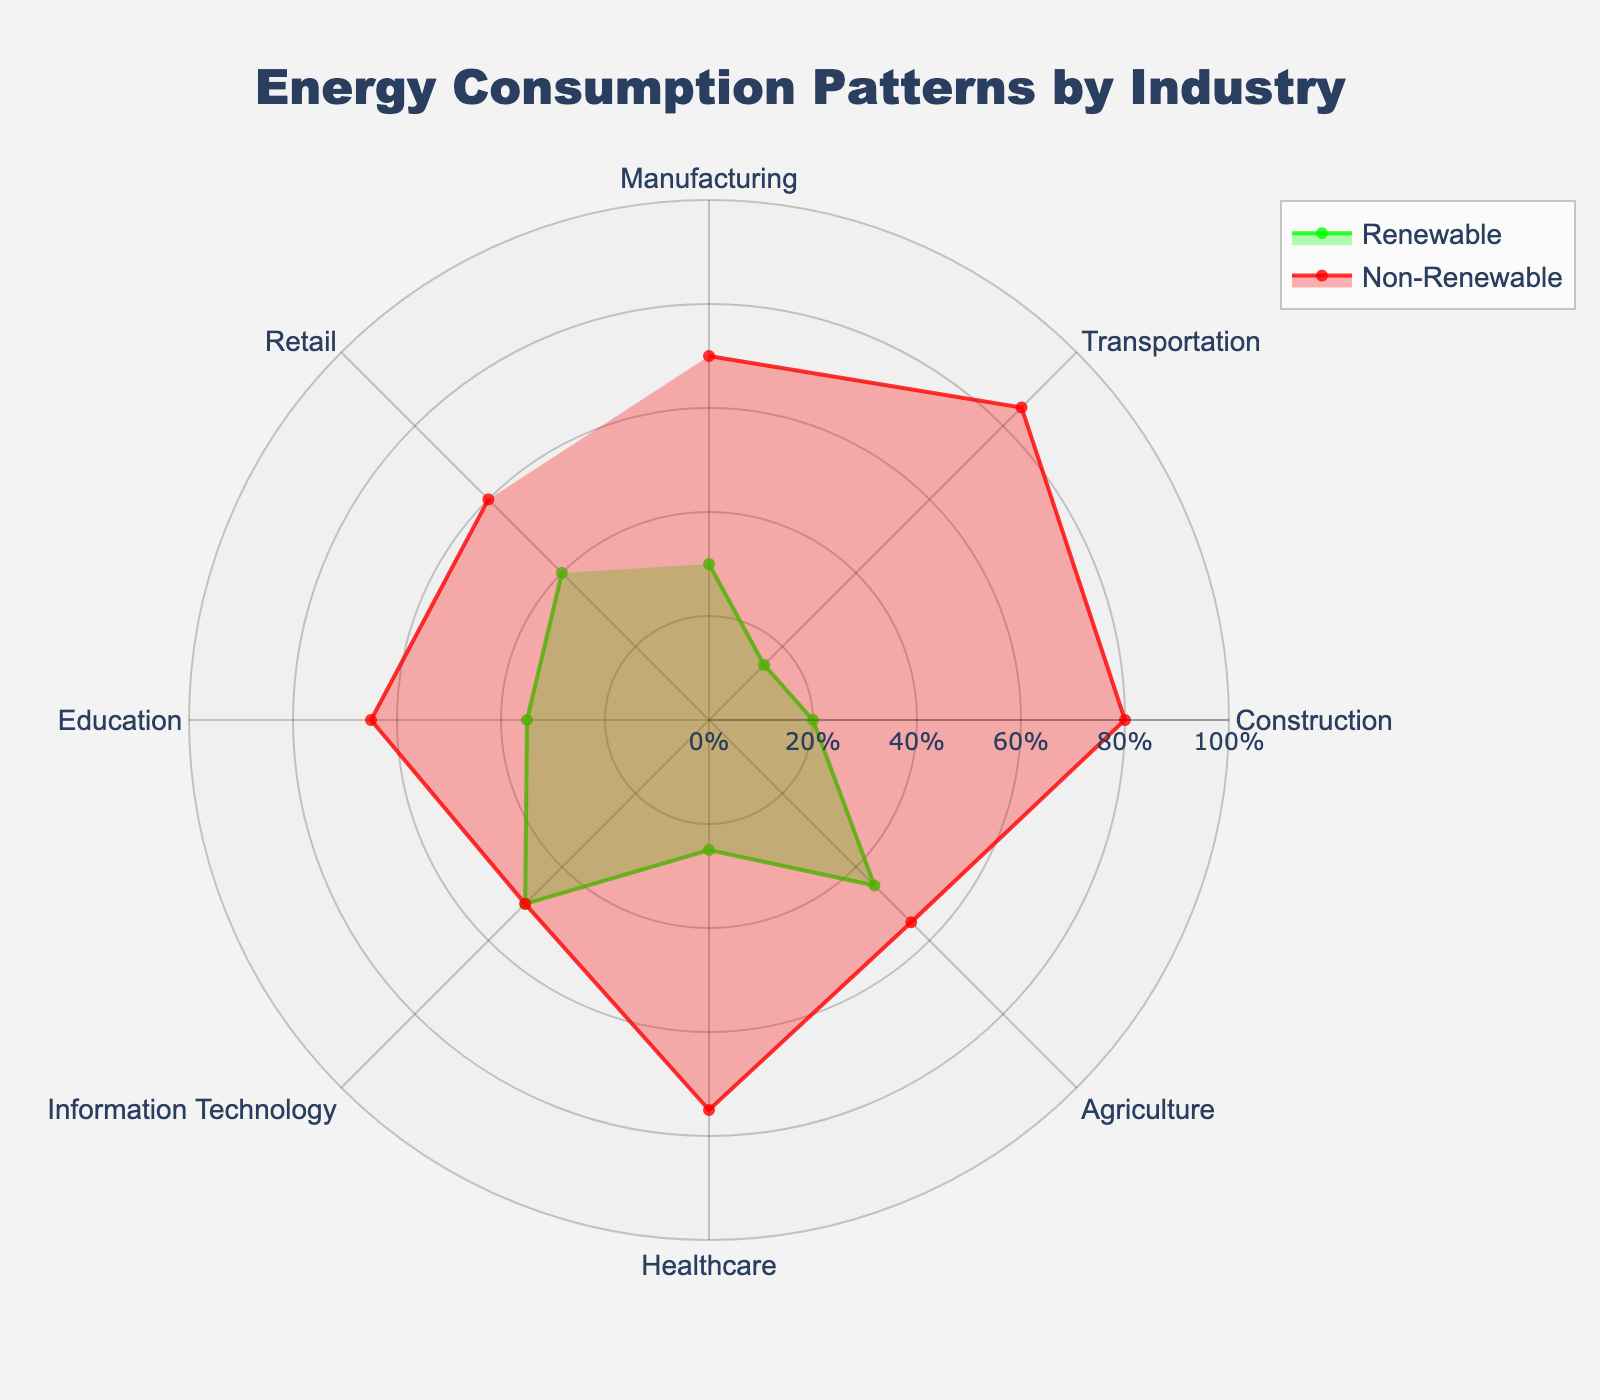What are the two main energy types represented in the chart? The chart shows two main energy types: Renewable and Non-Renewable. These types are plotted with distinct colors and visual markers.
Answer: Renewable and Non-Renewable Which industry has the highest percentage of renewable energy? In the chart, each industry is labeled, and their renewable energy percentages can be directly seen. Agriculture has the highest percentage of renewable energy at 45%.
Answer: Agriculture What is the title of the chart? The title is usually prominently displayed at the top of the chart. For this figure, the title is "Energy Consumption Patterns by Industry".
Answer: Energy Consumption Patterns by Industry Which industry has an equal distribution of renewable and non-renewable energy sources? By examining the percentages for each industry, Information Technology shows a 50/50 split between renewable and non-renewable energy.
Answer: Information Technology How much is the difference in renewable energy usage between Retail and Transportation? Retail has 40% renewable energy whereas Transportation has 15%. The difference is calculated as 40% - 15% = 25%.
Answer: 25% Which industry has the smallest percentage of renewable energy? The chart shows the renewable percentages for all industries, and Transportation has the smallest percentage at 15%.
Answer: Transportation Compare the renewable energy usage of the Healthcare and Education sectors. Which one is higher? Healthcare uses 25% renewable energy while Education uses 35%. Thus, Education has a higher percentage of renewable energy usage.
Answer: Education What is the average renewable energy percentage across all industries? To find the average, sum up all the renewable percentages and then divide by the number of industries. (30 + 15 + 20 + 45 + 25 + 50 + 35 + 40) / 8 = 32.5%
Answer: 32.5% How does the renewable energy usage in Manufacturing compare to Construction? Manufacturing has 30% renewable energy, while Construction has 20%. Manufacturing has a higher percentage.
Answer: Manufacturing Which industry uses 70% non-renewable energy, and how does this compare with its renewable energy usage? From the chart, Manufacturing uses 70% non-renewable energy and 30% renewable energy. There is a 40% difference between non-renewable and renewable usage.
Answer: Manufacturing 